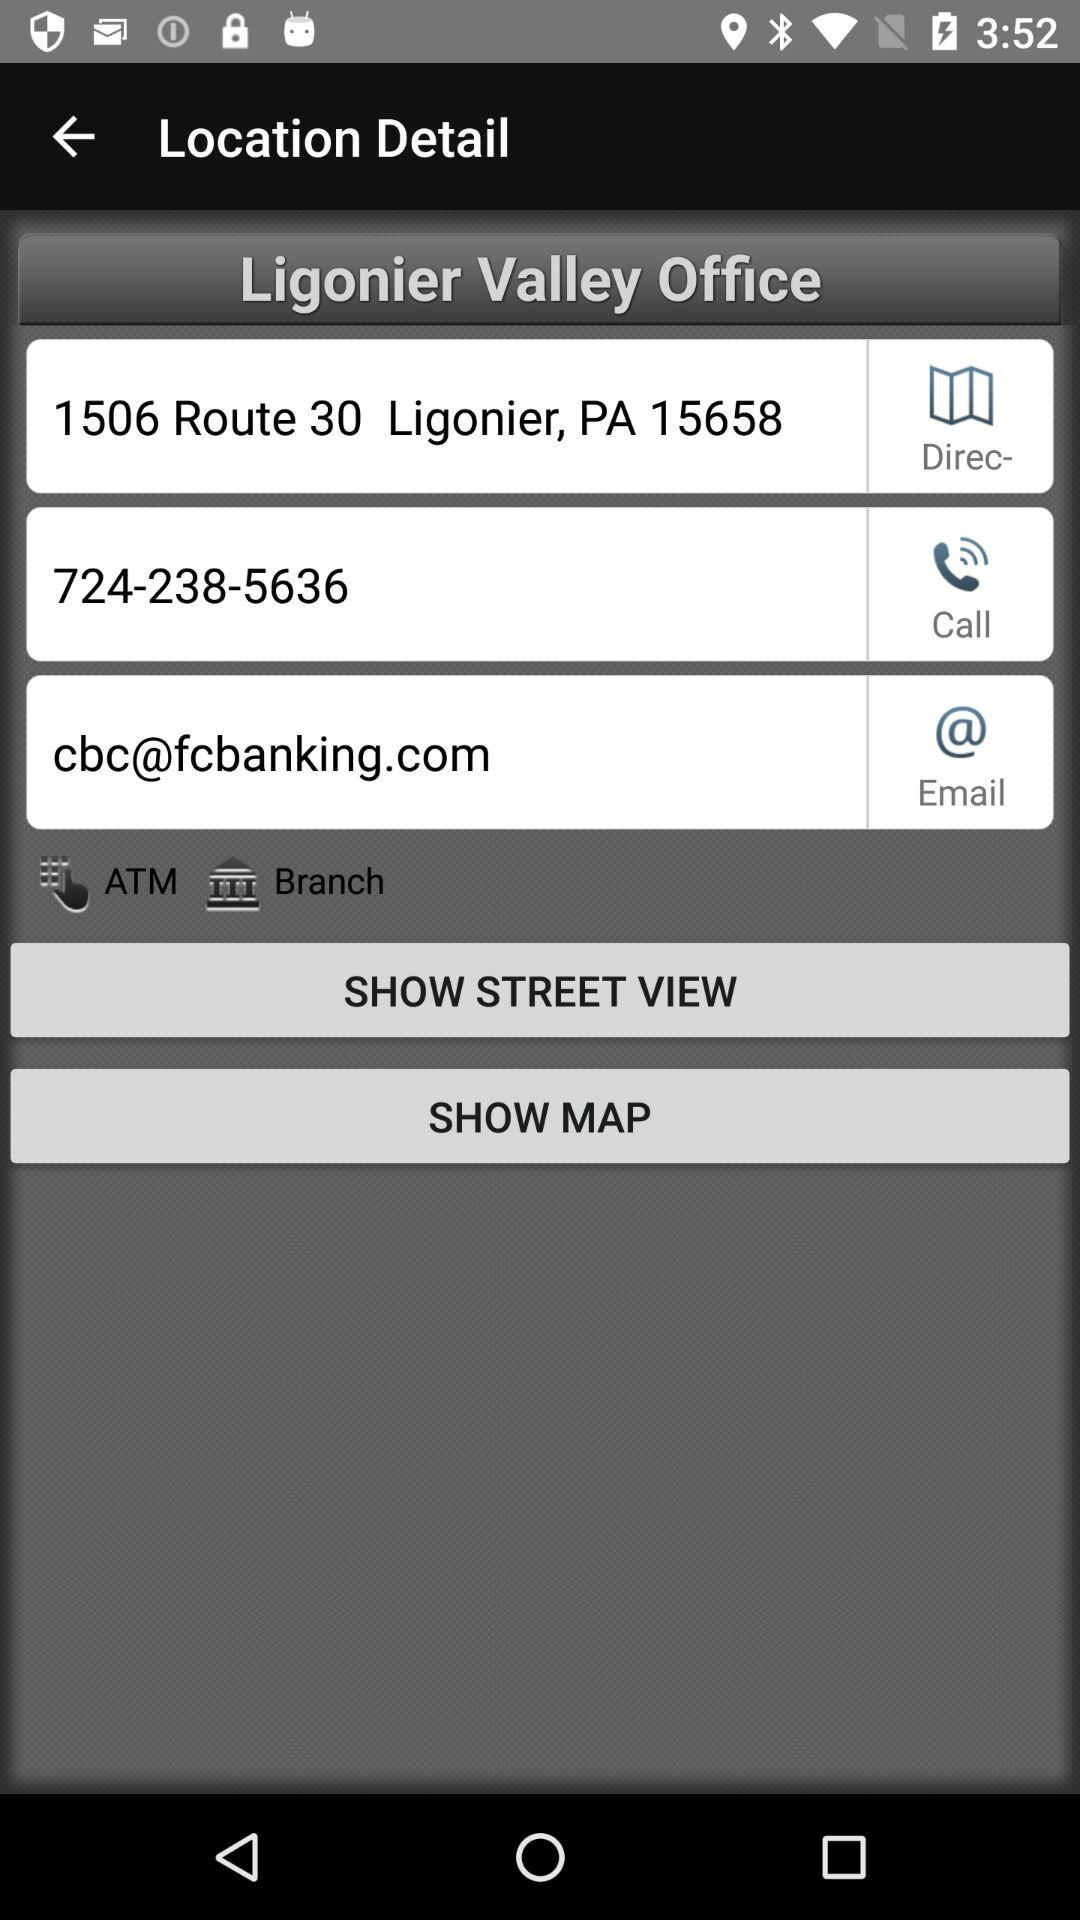What is the email address given for the Ligonier Valley office? The email address is cbc@fcbanking.com. 